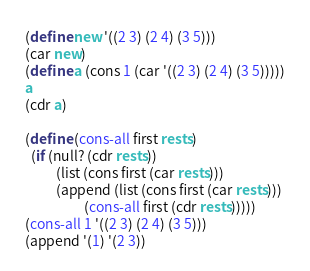<code> <loc_0><loc_0><loc_500><loc_500><_Scheme_>(define new '((2 3) (2 4) (3 5))) 
(car new)
(define a (cons 1 (car '((2 3) (2 4) (3 5)))))
a
(cdr a)

(define (cons-all first rests)
  (if (null? (cdr rests))
          (list (cons first (car rests)))
          (append (list (cons first (car rests)))
                   (cons-all first (cdr rests)))))
(cons-all 1 '((2 3) (2 4) (3 5)))
(append '(1) '(2 3))

</code> 